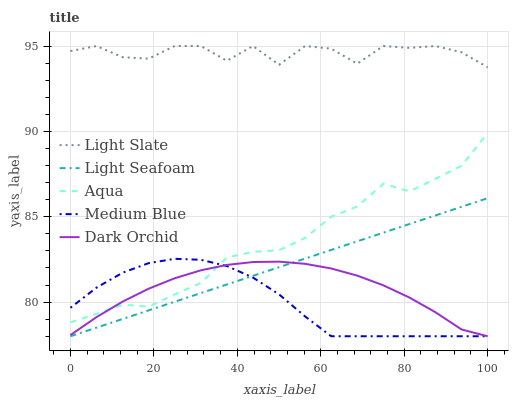Does Medium Blue have the minimum area under the curve?
Answer yes or no. Yes. Does Light Slate have the maximum area under the curve?
Answer yes or no. Yes. Does Light Seafoam have the minimum area under the curve?
Answer yes or no. No. Does Light Seafoam have the maximum area under the curve?
Answer yes or no. No. Is Light Seafoam the smoothest?
Answer yes or no. Yes. Is Light Slate the roughest?
Answer yes or no. Yes. Is Medium Blue the smoothest?
Answer yes or no. No. Is Medium Blue the roughest?
Answer yes or no. No. Does Medium Blue have the lowest value?
Answer yes or no. Yes. Does Aqua have the lowest value?
Answer yes or no. No. Does Light Slate have the highest value?
Answer yes or no. Yes. Does Medium Blue have the highest value?
Answer yes or no. No. Is Light Seafoam less than Aqua?
Answer yes or no. Yes. Is Light Slate greater than Light Seafoam?
Answer yes or no. Yes. Does Dark Orchid intersect Aqua?
Answer yes or no. Yes. Is Dark Orchid less than Aqua?
Answer yes or no. No. Is Dark Orchid greater than Aqua?
Answer yes or no. No. Does Light Seafoam intersect Aqua?
Answer yes or no. No. 